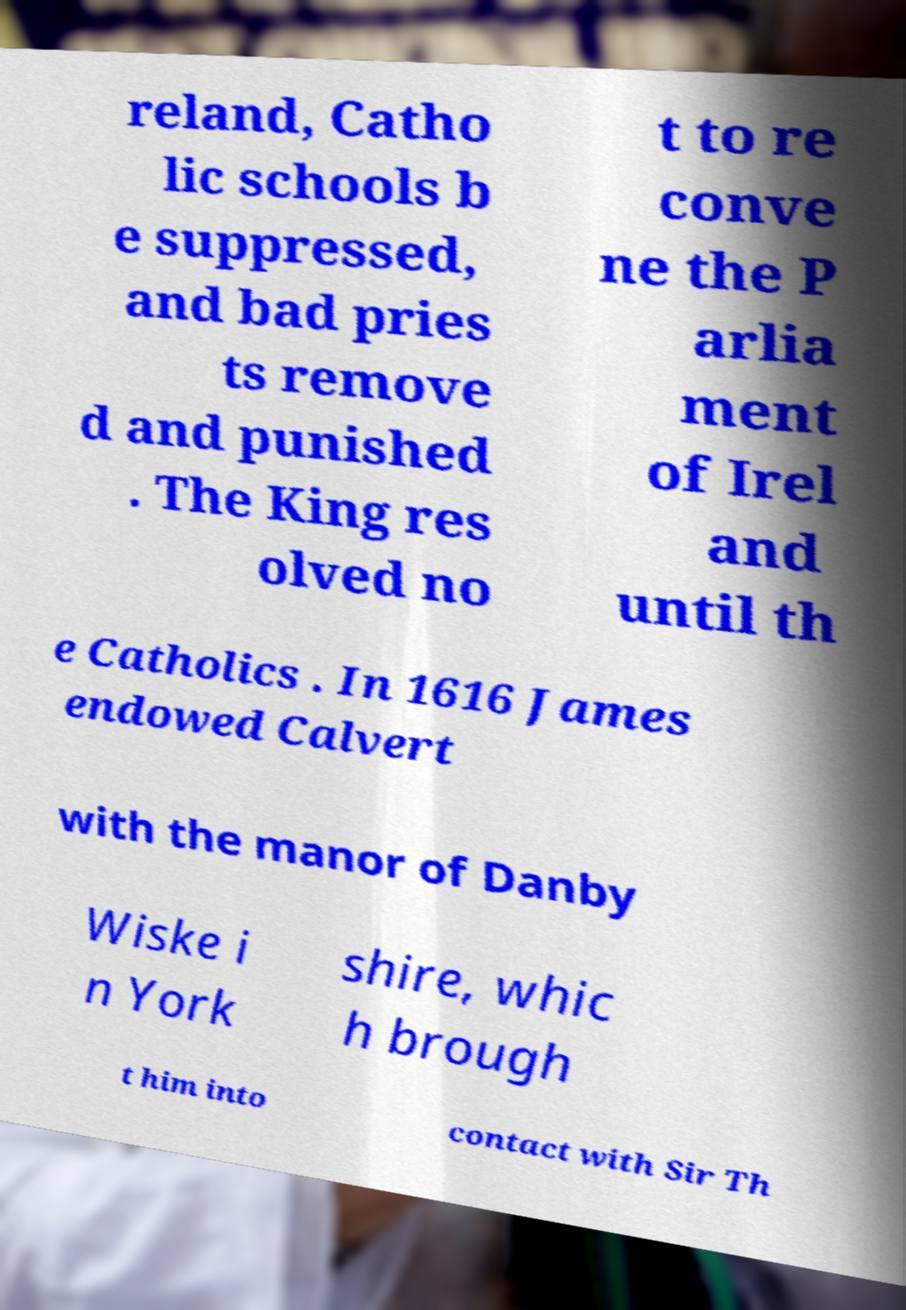Can you read and provide the text displayed in the image?This photo seems to have some interesting text. Can you extract and type it out for me? reland, Catho lic schools b e suppressed, and bad pries ts remove d and punished . The King res olved no t to re conve ne the P arlia ment of Irel and until th e Catholics . In 1616 James endowed Calvert with the manor of Danby Wiske i n York shire, whic h brough t him into contact with Sir Th 